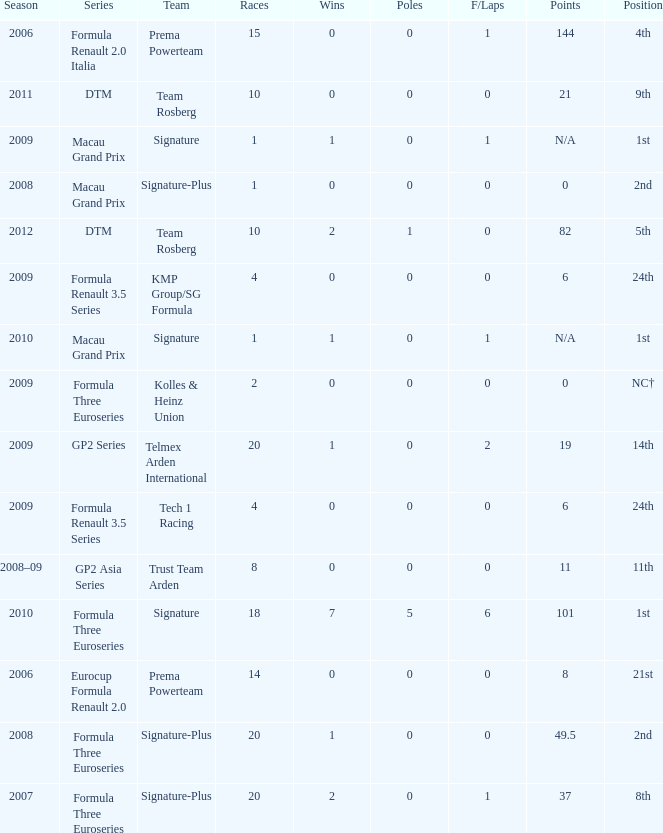How many races did the Formula Three Euroseries signature team have? 18.0. 